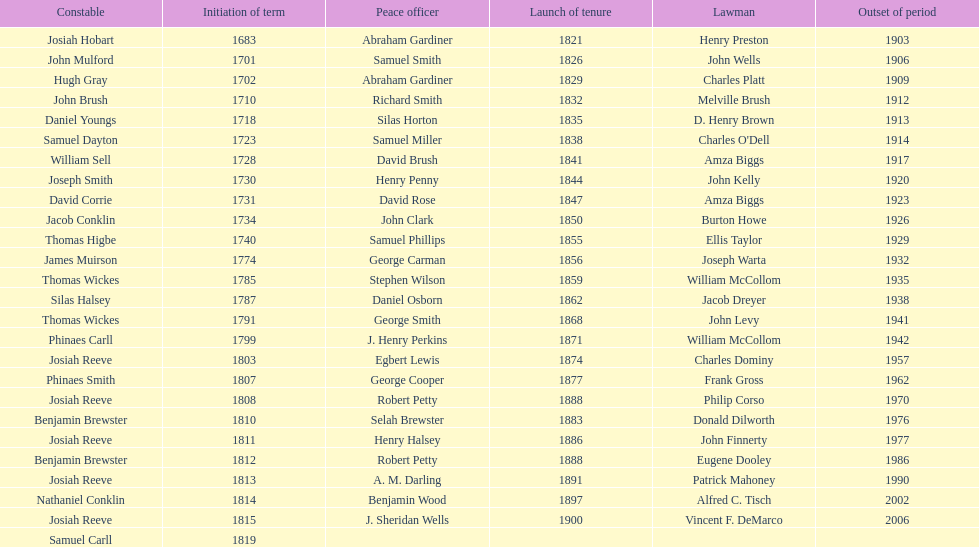When did the primary sheriff's term begin? 1683. 